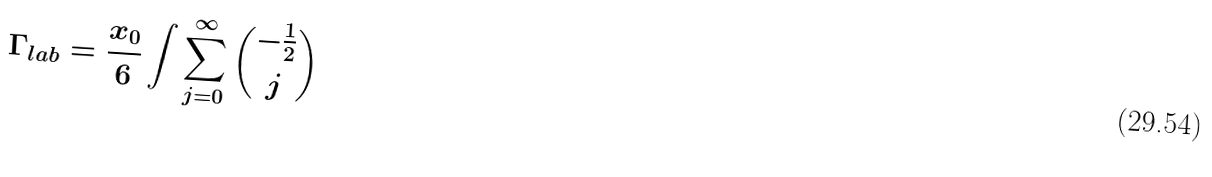<formula> <loc_0><loc_0><loc_500><loc_500>\Gamma _ { l a b } = \frac { x _ { 0 } } 6 \int \sum _ { j = 0 } ^ { \infty } { \binom { - \frac { 1 } { 2 } } j }</formula> 